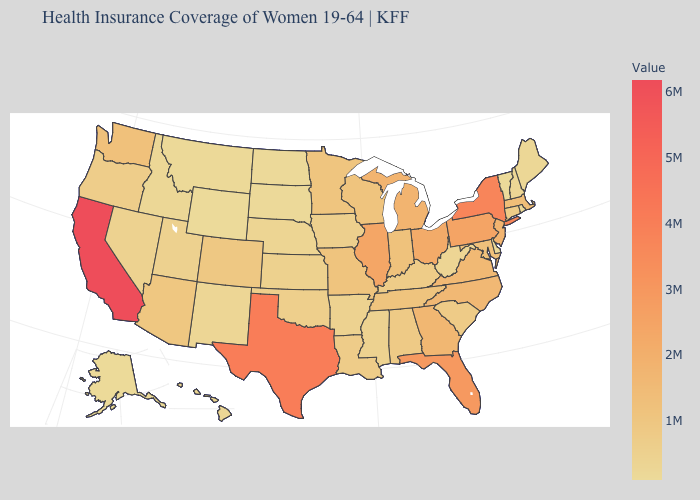Does New Mexico have the highest value in the West?
Quick response, please. No. Does the map have missing data?
Give a very brief answer. No. Which states hav the highest value in the Northeast?
Write a very short answer. New York. Which states have the lowest value in the USA?
Quick response, please. Wyoming. Does Minnesota have the lowest value in the MidWest?
Keep it brief. No. 